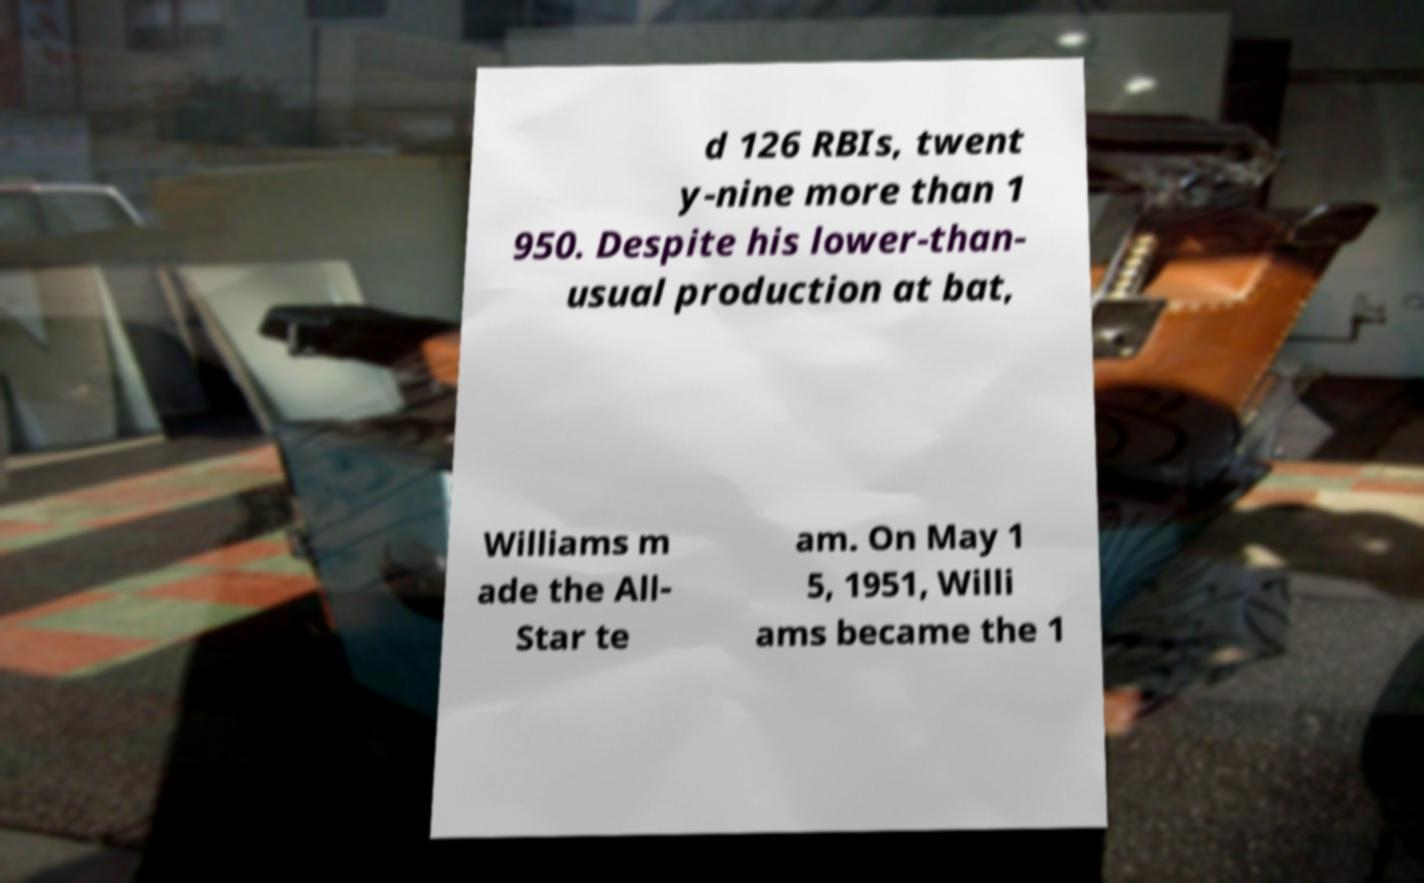For documentation purposes, I need the text within this image transcribed. Could you provide that? d 126 RBIs, twent y-nine more than 1 950. Despite his lower-than- usual production at bat, Williams m ade the All- Star te am. On May 1 5, 1951, Willi ams became the 1 